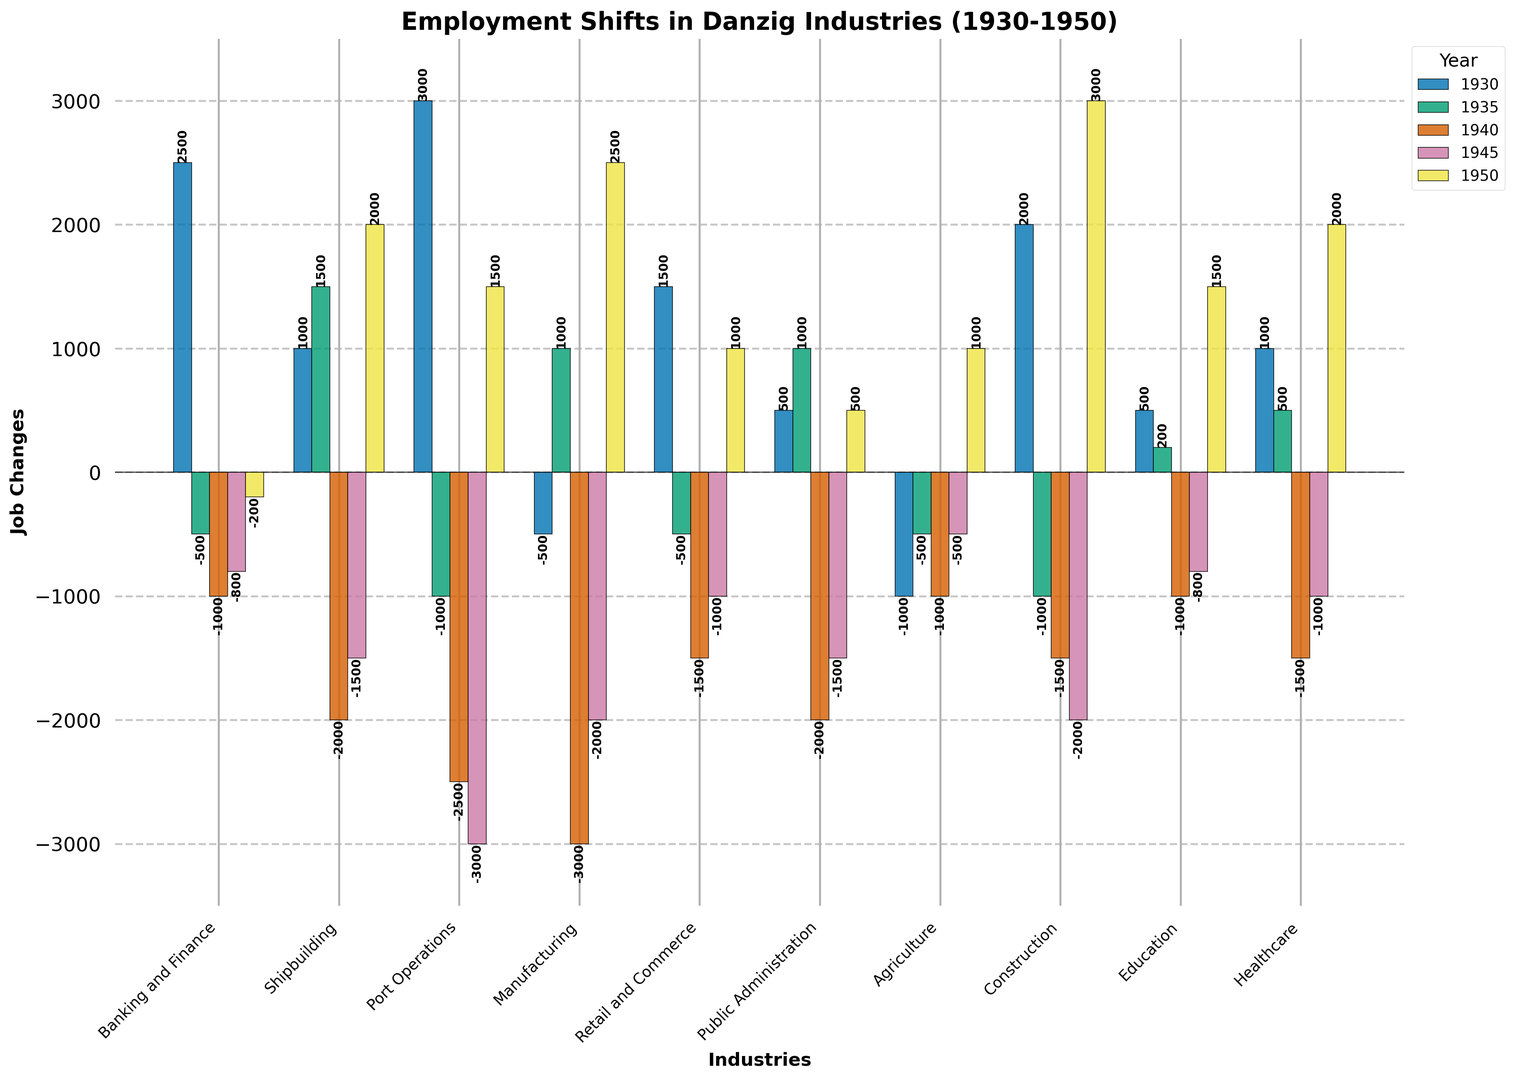Which industry had the highest job gains in 1950? Compare the heights of bars for each industry in the year 1950. Construction had the highest job gain as its bar is the tallest in 1950.
Answer: Construction Which industry had the largest job loss in 1940? Compare the lengths of the bars in 1940 that dip below the zero line to identify the largest negative value. Manufacturing experienced the largest job loss as it has the longest bar below the zero line in 1940.
Answer: Manufacturing What is the total job change in Construction over all the years? Sum up the job changes for Construction across all given years: 2000 + (-1000) + (-1500) + (-2000) + 3000 = 500.
Answer: 500 Which industry shows alternating job gains and losses over the years? Observe the pattern of bars switching between positive and negative for each industry. Retail and Commerce had alternating job gains and losses: 1500 (gain), -500 (loss), -1500 (loss), -1000 (loss), 1000 (gain).
Answer: Retail and Commerce Compare the job losses in Shipbuilding in 1940 and 1945. Which year had a greater loss? Compare the heights of the bars below the zero line for Shipbuilding in 1940 and 1945. The bar in 1940 extends further down than the one in 1945, indicating greater job loss in 1940.
Answer: 1940 Which two industries have the same job change value in 1935 and what is that value? Look for bars of the same height in 1935. Public Administration and Manufacturing both have bars of the same height in 1935 (1000).
Answer: Public Administration and Manufacturing, 1000 Which industry had the most consistent job changes with minimal negative values across the years? Observe all years to identify the industry with minimal fluctuations and least negative values. Education had the most consistent job changes with minimal negative values until 1950.
Answer: Education What is the net job change in Agriculture over all the years? Sum up the job changes for Agriculture: -1000 + (-500) + (-1000) + (-500) + 1000 = -2000.
Answer: -2000 Compare the total job changes across all industries for the year 1930. Which had the largest positive change? Observe the bars in 1930 and identify the highest one. Port Operations had the largest positive change in 1930 with 3000.
Answer: Port Operations 